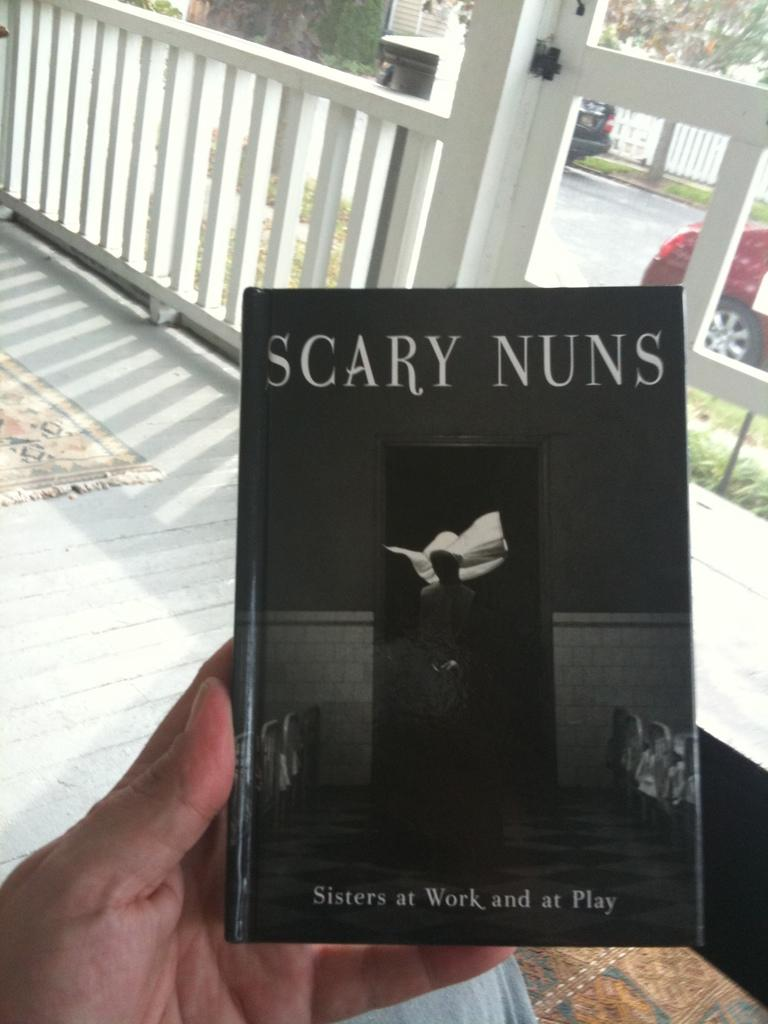<image>
Share a concise interpretation of the image provided. Someone is on a porch holding a copy of the book Scary Nuns. 